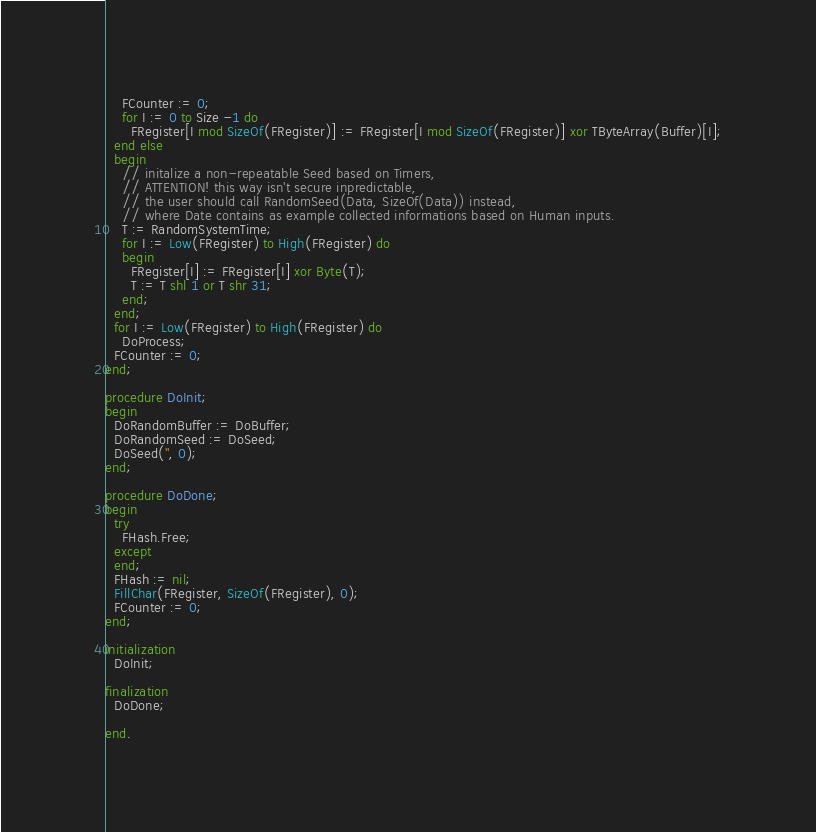<code> <loc_0><loc_0><loc_500><loc_500><_Pascal_>    FCounter := 0;
    for I := 0 to Size -1 do
      FRegister[I mod SizeOf(FRegister)] := FRegister[I mod SizeOf(FRegister)] xor TByteArray(Buffer)[I];
  end else
  begin
    // initalize a non-repeatable Seed based on Timers,
    // ATTENTION! this way isn't secure inpredictable,
    // the user should call RandomSeed(Data, SizeOf(Data)) instead,
    // where Date contains as example collected informations based on Human inputs.
    T := RandomSystemTime;
    for I := Low(FRegister) to High(FRegister) do
    begin
      FRegister[I] := FRegister[I] xor Byte(T);
      T := T shl 1 or T shr 31;
    end;
  end;
  for I := Low(FRegister) to High(FRegister) do
    DoProcess;
  FCounter := 0;
end;

procedure DoInit;
begin
  DoRandomBuffer := DoBuffer;
  DoRandomSeed := DoSeed;
  DoSeed('', 0);
end;

procedure DoDone;
begin
  try
    FHash.Free;
  except
  end;
  FHash := nil;
  FillChar(FRegister, SizeOf(FRegister), 0);
  FCounter := 0;
end;

initialization
  DoInit;

finalization
  DoDone;

end.
</code> 